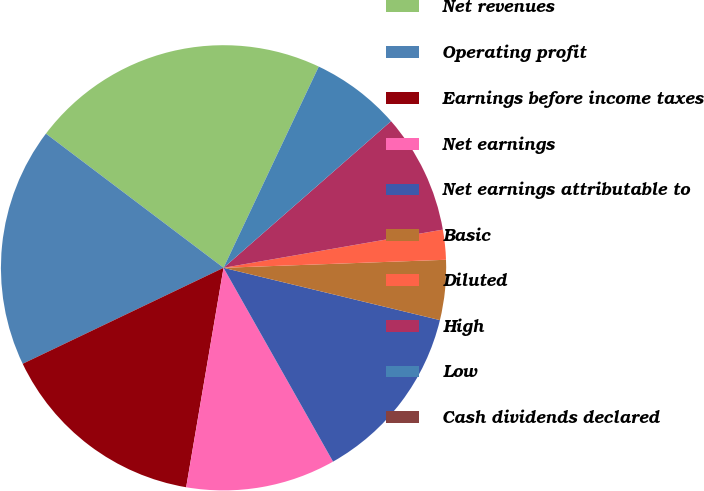<chart> <loc_0><loc_0><loc_500><loc_500><pie_chart><fcel>Net revenues<fcel>Operating profit<fcel>Earnings before income taxes<fcel>Net earnings<fcel>Net earnings attributable to<fcel>Basic<fcel>Diluted<fcel>High<fcel>Low<fcel>Cash dividends declared<nl><fcel>21.74%<fcel>17.39%<fcel>15.22%<fcel>10.87%<fcel>13.04%<fcel>4.35%<fcel>2.17%<fcel>8.7%<fcel>6.52%<fcel>0.0%<nl></chart> 